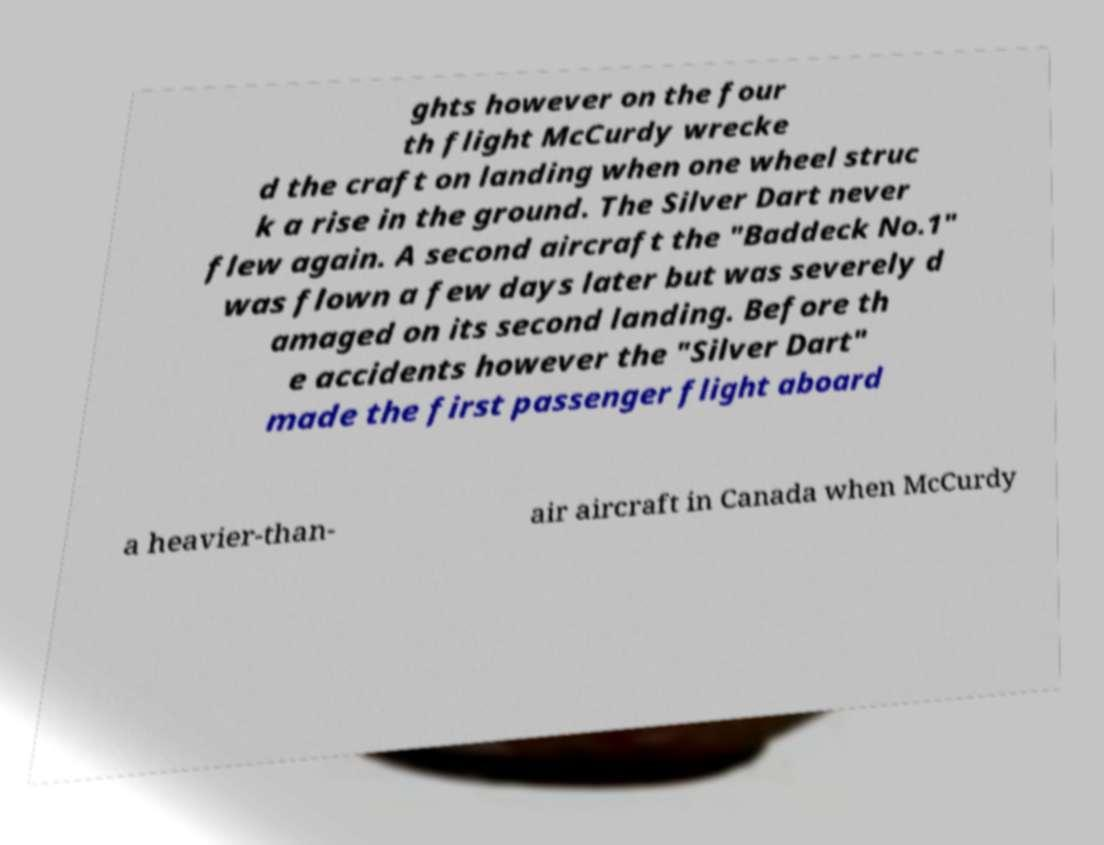Can you read and provide the text displayed in the image?This photo seems to have some interesting text. Can you extract and type it out for me? ghts however on the four th flight McCurdy wrecke d the craft on landing when one wheel struc k a rise in the ground. The Silver Dart never flew again. A second aircraft the "Baddeck No.1" was flown a few days later but was severely d amaged on its second landing. Before th e accidents however the "Silver Dart" made the first passenger flight aboard a heavier-than- air aircraft in Canada when McCurdy 